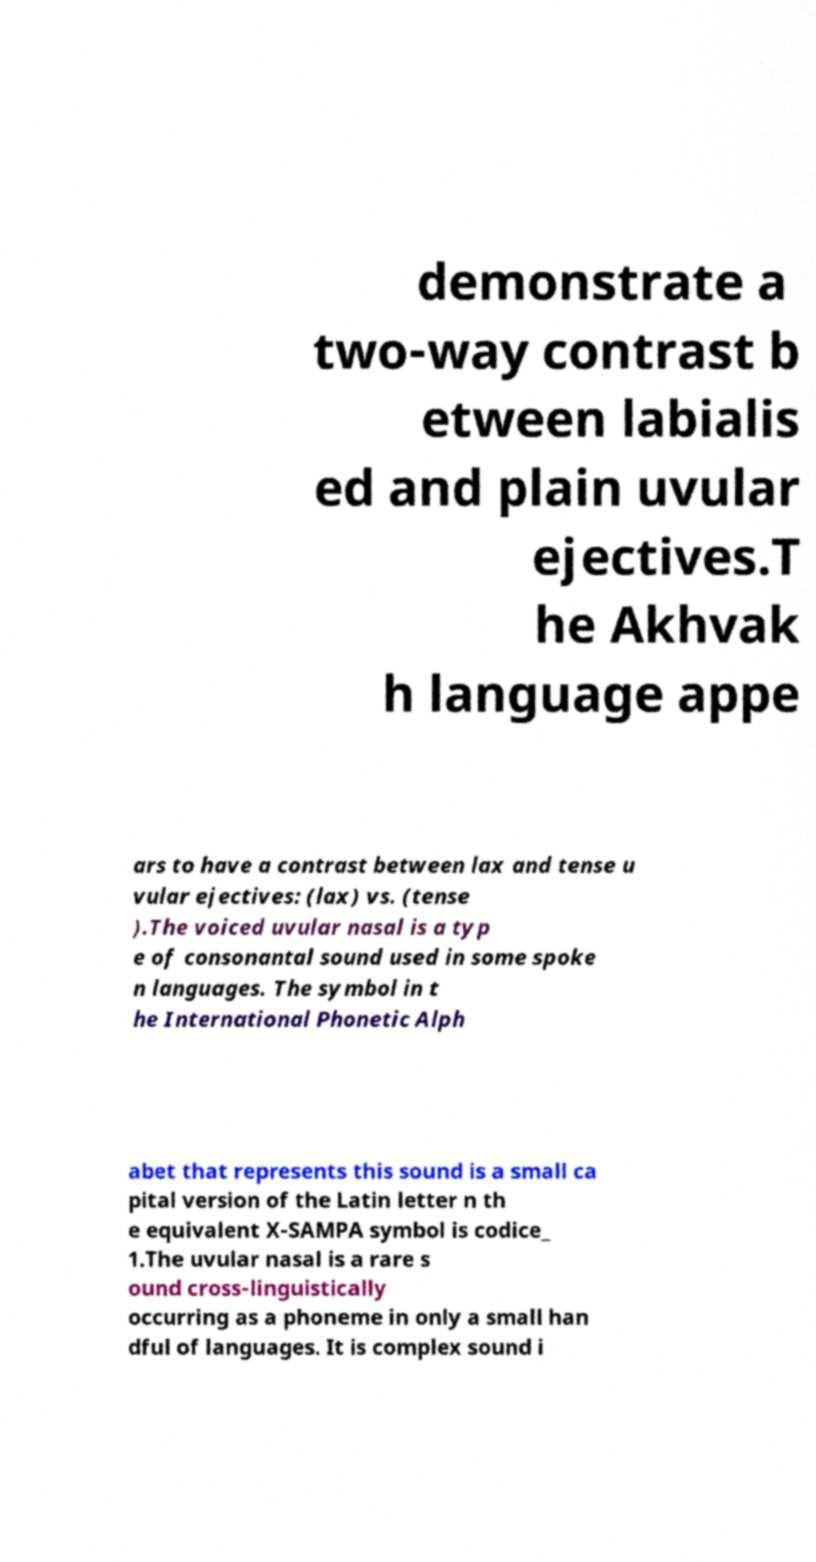Could you assist in decoding the text presented in this image and type it out clearly? demonstrate a two-way contrast b etween labialis ed and plain uvular ejectives.T he Akhvak h language appe ars to have a contrast between lax and tense u vular ejectives: (lax) vs. (tense ).The voiced uvular nasal is a typ e of consonantal sound used in some spoke n languages. The symbol in t he International Phonetic Alph abet that represents this sound is a small ca pital version of the Latin letter n th e equivalent X-SAMPA symbol is codice_ 1.The uvular nasal is a rare s ound cross-linguistically occurring as a phoneme in only a small han dful of languages. It is complex sound i 